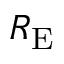<formula> <loc_0><loc_0><loc_500><loc_500>R _ { E }</formula> 